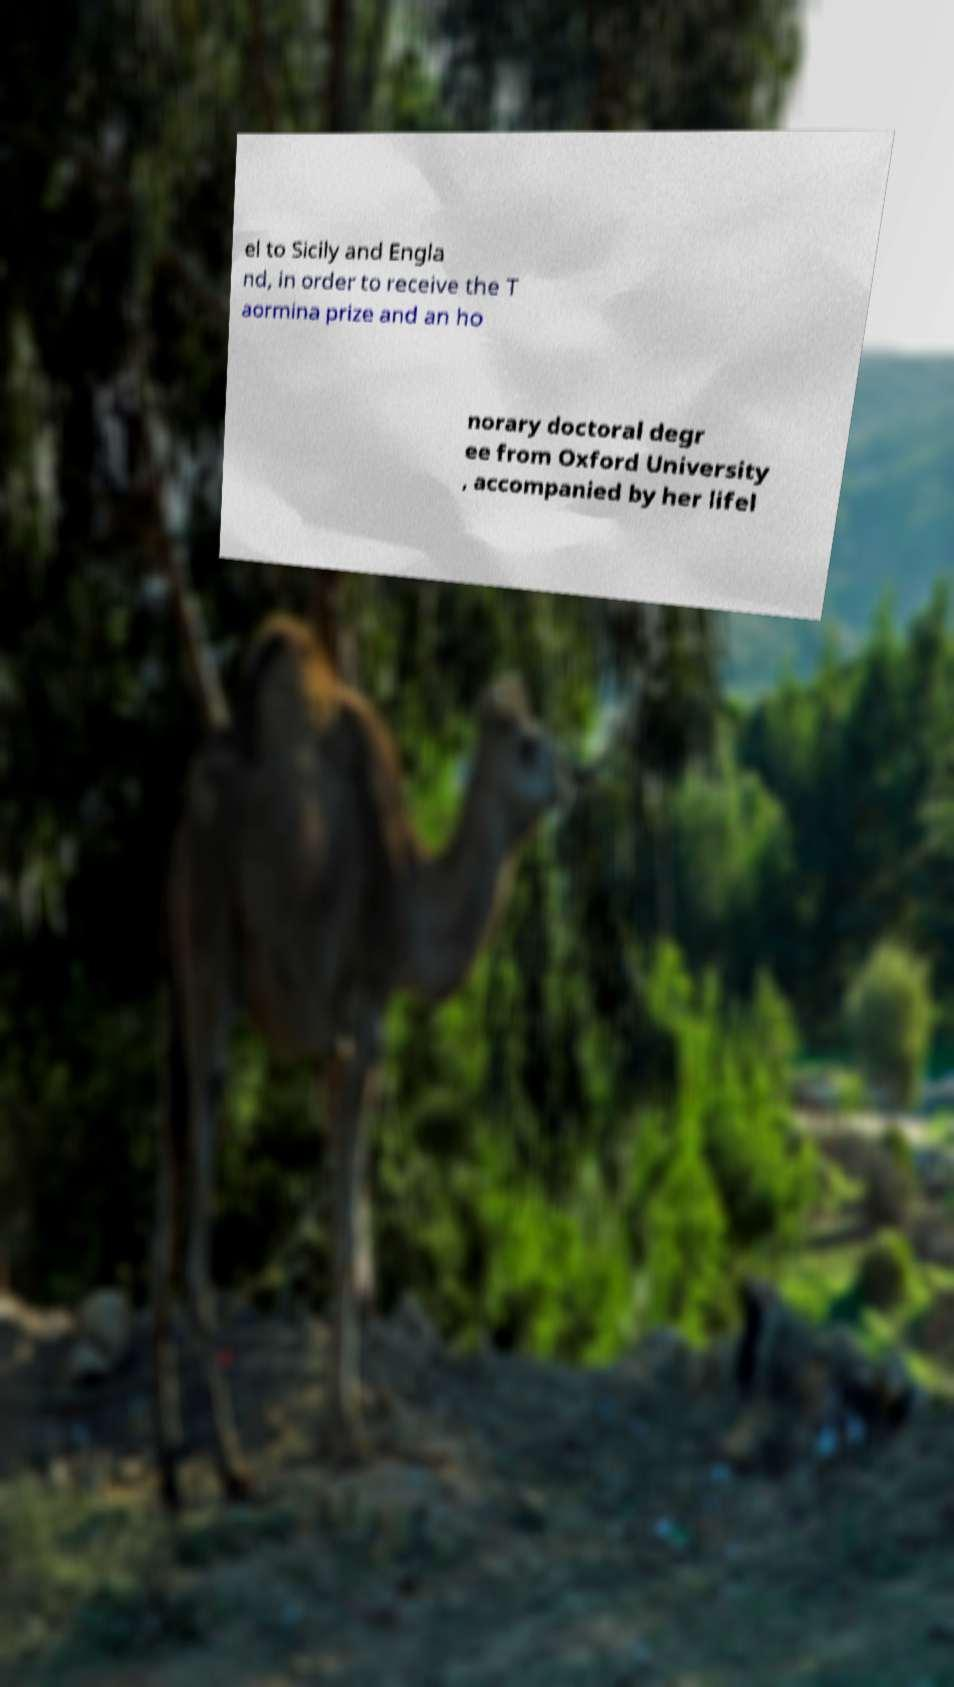I need the written content from this picture converted into text. Can you do that? el to Sicily and Engla nd, in order to receive the T aormina prize and an ho norary doctoral degr ee from Oxford University , accompanied by her lifel 